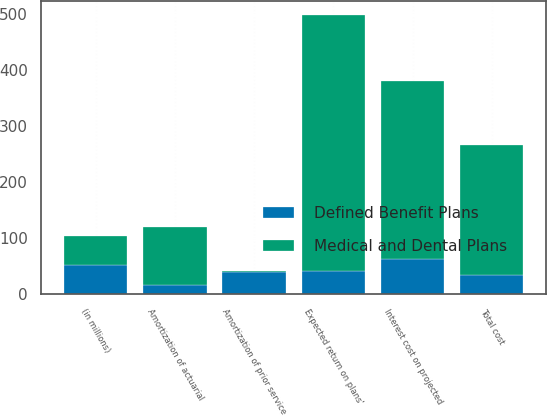Convert chart to OTSL. <chart><loc_0><loc_0><loc_500><loc_500><stacked_bar_chart><ecel><fcel>(in millions)<fcel>Interest cost on projected<fcel>Expected return on plans'<fcel>Amortization of actuarial<fcel>Amortization of prior service<fcel>Total cost<nl><fcel>Medical and Dental Plans<fcel>51.5<fcel>317<fcel>458<fcel>103<fcel>2<fcel>233<nl><fcel>Defined Benefit Plans<fcel>51.5<fcel>63<fcel>40<fcel>16<fcel>39<fcel>33<nl></chart> 